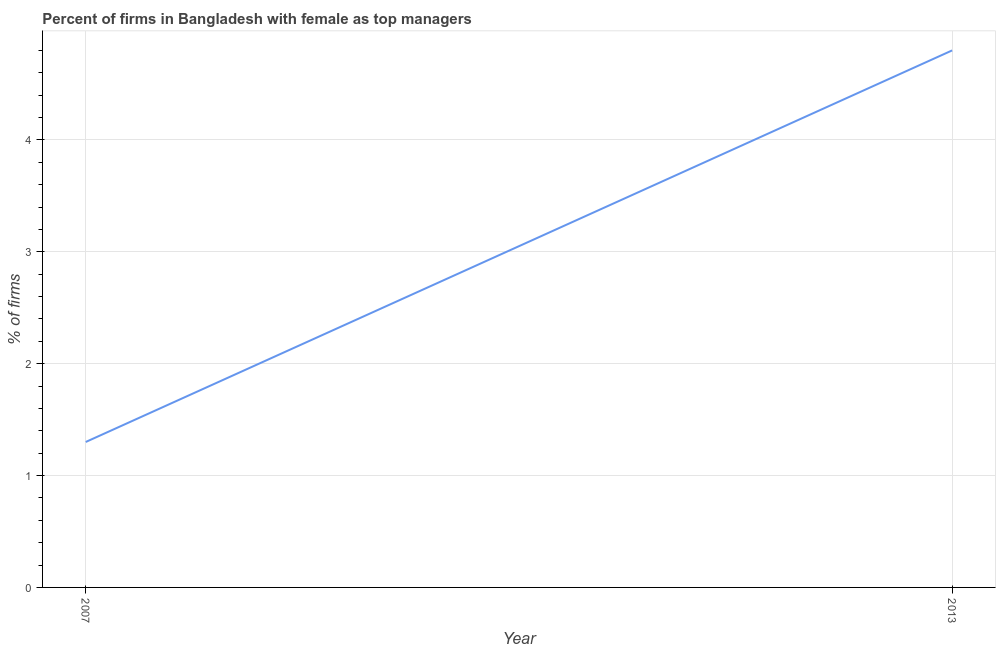What is the average percentage of firms with female as top manager per year?
Provide a short and direct response. 3.05. What is the median percentage of firms with female as top manager?
Make the answer very short. 3.05. In how many years, is the percentage of firms with female as top manager greater than 1 %?
Provide a short and direct response. 2. What is the ratio of the percentage of firms with female as top manager in 2007 to that in 2013?
Ensure brevity in your answer.  0.27. Is the percentage of firms with female as top manager in 2007 less than that in 2013?
Your answer should be very brief. Yes. How many years are there in the graph?
Offer a very short reply. 2. Are the values on the major ticks of Y-axis written in scientific E-notation?
Ensure brevity in your answer.  No. Does the graph contain grids?
Ensure brevity in your answer.  Yes. What is the title of the graph?
Keep it short and to the point. Percent of firms in Bangladesh with female as top managers. What is the label or title of the X-axis?
Offer a very short reply. Year. What is the label or title of the Y-axis?
Keep it short and to the point. % of firms. What is the % of firms in 2007?
Offer a very short reply. 1.3. What is the % of firms of 2013?
Ensure brevity in your answer.  4.8. What is the ratio of the % of firms in 2007 to that in 2013?
Provide a succinct answer. 0.27. 